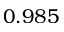Convert formula to latex. <formula><loc_0><loc_0><loc_500><loc_500>0 . 9 8 5</formula> 